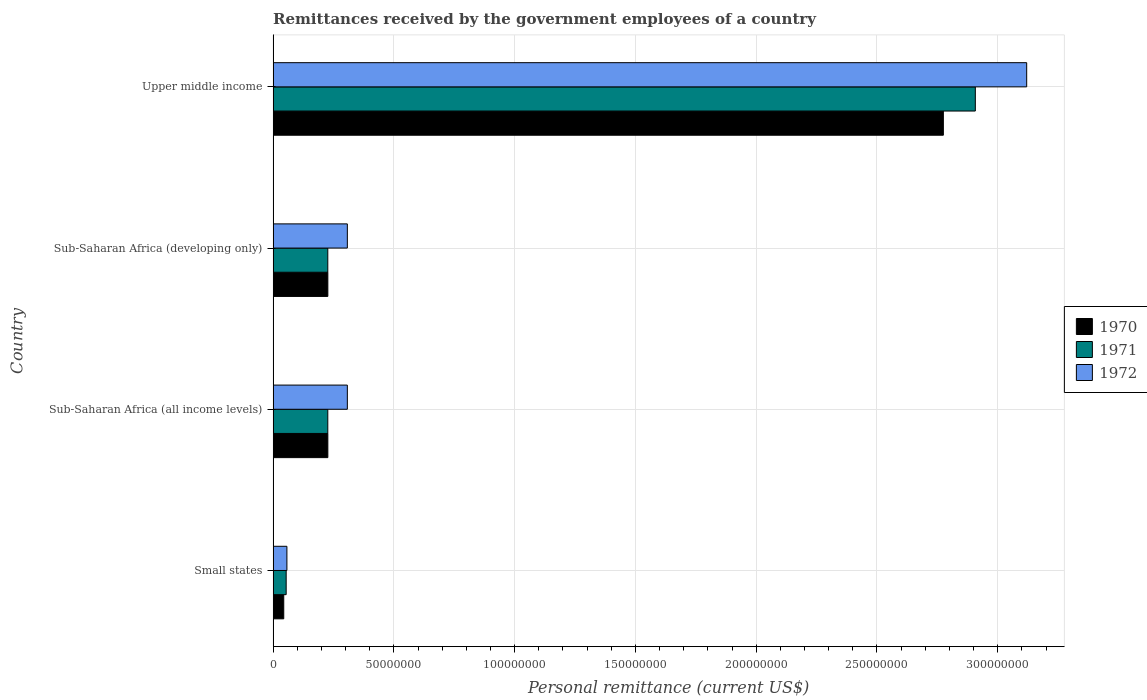How many bars are there on the 2nd tick from the top?
Offer a terse response. 3. What is the label of the 3rd group of bars from the top?
Your answer should be compact. Sub-Saharan Africa (all income levels). What is the remittances received by the government employees in 1971 in Small states?
Your answer should be compact. 5.40e+06. Across all countries, what is the maximum remittances received by the government employees in 1971?
Provide a short and direct response. 2.91e+08. Across all countries, what is the minimum remittances received by the government employees in 1970?
Make the answer very short. 4.40e+06. In which country was the remittances received by the government employees in 1972 maximum?
Give a very brief answer. Upper middle income. In which country was the remittances received by the government employees in 1970 minimum?
Provide a succinct answer. Small states. What is the total remittances received by the government employees in 1970 in the graph?
Provide a succinct answer. 3.27e+08. What is the difference between the remittances received by the government employees in 1970 in Sub-Saharan Africa (all income levels) and that in Sub-Saharan Africa (developing only)?
Offer a very short reply. 0. What is the difference between the remittances received by the government employees in 1972 in Sub-Saharan Africa (developing only) and the remittances received by the government employees in 1971 in Sub-Saharan Africa (all income levels)?
Offer a terse response. 8.09e+06. What is the average remittances received by the government employees in 1972 per country?
Your answer should be very brief. 9.48e+07. What is the difference between the remittances received by the government employees in 1970 and remittances received by the government employees in 1972 in Sub-Saharan Africa (all income levels)?
Ensure brevity in your answer.  -8.07e+06. What is the ratio of the remittances received by the government employees in 1970 in Sub-Saharan Africa (developing only) to that in Upper middle income?
Your response must be concise. 0.08. What is the difference between the highest and the second highest remittances received by the government employees in 1972?
Offer a very short reply. 2.81e+08. What is the difference between the highest and the lowest remittances received by the government employees in 1970?
Your answer should be compact. 2.73e+08. In how many countries, is the remittances received by the government employees in 1972 greater than the average remittances received by the government employees in 1972 taken over all countries?
Ensure brevity in your answer.  1. Is the sum of the remittances received by the government employees in 1972 in Sub-Saharan Africa (all income levels) and Upper middle income greater than the maximum remittances received by the government employees in 1971 across all countries?
Your response must be concise. Yes. What does the 1st bar from the top in Upper middle income represents?
Offer a very short reply. 1972. What does the 2nd bar from the bottom in Small states represents?
Your answer should be very brief. 1971. Are all the bars in the graph horizontal?
Ensure brevity in your answer.  Yes. How many countries are there in the graph?
Keep it short and to the point. 4. Are the values on the major ticks of X-axis written in scientific E-notation?
Give a very brief answer. No. Does the graph contain grids?
Provide a short and direct response. Yes. How many legend labels are there?
Offer a terse response. 3. How are the legend labels stacked?
Make the answer very short. Vertical. What is the title of the graph?
Provide a succinct answer. Remittances received by the government employees of a country. Does "2015" appear as one of the legend labels in the graph?
Your answer should be compact. No. What is the label or title of the X-axis?
Ensure brevity in your answer.  Personal remittance (current US$). What is the Personal remittance (current US$) of 1970 in Small states?
Keep it short and to the point. 4.40e+06. What is the Personal remittance (current US$) in 1971 in Small states?
Your answer should be compact. 5.40e+06. What is the Personal remittance (current US$) in 1972 in Small states?
Your answer should be compact. 5.71e+06. What is the Personal remittance (current US$) of 1970 in Sub-Saharan Africa (all income levels)?
Make the answer very short. 2.27e+07. What is the Personal remittance (current US$) of 1971 in Sub-Saharan Africa (all income levels)?
Ensure brevity in your answer.  2.26e+07. What is the Personal remittance (current US$) of 1972 in Sub-Saharan Africa (all income levels)?
Your answer should be compact. 3.07e+07. What is the Personal remittance (current US$) of 1970 in Sub-Saharan Africa (developing only)?
Keep it short and to the point. 2.27e+07. What is the Personal remittance (current US$) of 1971 in Sub-Saharan Africa (developing only)?
Provide a succinct answer. 2.26e+07. What is the Personal remittance (current US$) in 1972 in Sub-Saharan Africa (developing only)?
Make the answer very short. 3.07e+07. What is the Personal remittance (current US$) of 1970 in Upper middle income?
Keep it short and to the point. 2.77e+08. What is the Personal remittance (current US$) of 1971 in Upper middle income?
Offer a terse response. 2.91e+08. What is the Personal remittance (current US$) in 1972 in Upper middle income?
Provide a succinct answer. 3.12e+08. Across all countries, what is the maximum Personal remittance (current US$) of 1970?
Provide a short and direct response. 2.77e+08. Across all countries, what is the maximum Personal remittance (current US$) of 1971?
Keep it short and to the point. 2.91e+08. Across all countries, what is the maximum Personal remittance (current US$) of 1972?
Provide a short and direct response. 3.12e+08. Across all countries, what is the minimum Personal remittance (current US$) of 1970?
Make the answer very short. 4.40e+06. Across all countries, what is the minimum Personal remittance (current US$) of 1971?
Provide a short and direct response. 5.40e+06. Across all countries, what is the minimum Personal remittance (current US$) of 1972?
Make the answer very short. 5.71e+06. What is the total Personal remittance (current US$) in 1970 in the graph?
Your response must be concise. 3.27e+08. What is the total Personal remittance (current US$) in 1971 in the graph?
Provide a succinct answer. 3.41e+08. What is the total Personal remittance (current US$) of 1972 in the graph?
Provide a short and direct response. 3.79e+08. What is the difference between the Personal remittance (current US$) in 1970 in Small states and that in Sub-Saharan Africa (all income levels)?
Your answer should be compact. -1.83e+07. What is the difference between the Personal remittance (current US$) of 1971 in Small states and that in Sub-Saharan Africa (all income levels)?
Keep it short and to the point. -1.72e+07. What is the difference between the Personal remittance (current US$) of 1972 in Small states and that in Sub-Saharan Africa (all income levels)?
Provide a succinct answer. -2.50e+07. What is the difference between the Personal remittance (current US$) of 1970 in Small states and that in Sub-Saharan Africa (developing only)?
Your response must be concise. -1.83e+07. What is the difference between the Personal remittance (current US$) of 1971 in Small states and that in Sub-Saharan Africa (developing only)?
Make the answer very short. -1.72e+07. What is the difference between the Personal remittance (current US$) of 1972 in Small states and that in Sub-Saharan Africa (developing only)?
Give a very brief answer. -2.50e+07. What is the difference between the Personal remittance (current US$) in 1970 in Small states and that in Upper middle income?
Keep it short and to the point. -2.73e+08. What is the difference between the Personal remittance (current US$) in 1971 in Small states and that in Upper middle income?
Keep it short and to the point. -2.85e+08. What is the difference between the Personal remittance (current US$) of 1972 in Small states and that in Upper middle income?
Your answer should be compact. -3.06e+08. What is the difference between the Personal remittance (current US$) of 1972 in Sub-Saharan Africa (all income levels) and that in Sub-Saharan Africa (developing only)?
Your response must be concise. 0. What is the difference between the Personal remittance (current US$) of 1970 in Sub-Saharan Africa (all income levels) and that in Upper middle income?
Your answer should be compact. -2.55e+08. What is the difference between the Personal remittance (current US$) in 1971 in Sub-Saharan Africa (all income levels) and that in Upper middle income?
Make the answer very short. -2.68e+08. What is the difference between the Personal remittance (current US$) of 1972 in Sub-Saharan Africa (all income levels) and that in Upper middle income?
Provide a succinct answer. -2.81e+08. What is the difference between the Personal remittance (current US$) of 1970 in Sub-Saharan Africa (developing only) and that in Upper middle income?
Make the answer very short. -2.55e+08. What is the difference between the Personal remittance (current US$) of 1971 in Sub-Saharan Africa (developing only) and that in Upper middle income?
Your answer should be compact. -2.68e+08. What is the difference between the Personal remittance (current US$) of 1972 in Sub-Saharan Africa (developing only) and that in Upper middle income?
Keep it short and to the point. -2.81e+08. What is the difference between the Personal remittance (current US$) of 1970 in Small states and the Personal remittance (current US$) of 1971 in Sub-Saharan Africa (all income levels)?
Make the answer very short. -1.82e+07. What is the difference between the Personal remittance (current US$) in 1970 in Small states and the Personal remittance (current US$) in 1972 in Sub-Saharan Africa (all income levels)?
Keep it short and to the point. -2.63e+07. What is the difference between the Personal remittance (current US$) in 1971 in Small states and the Personal remittance (current US$) in 1972 in Sub-Saharan Africa (all income levels)?
Provide a short and direct response. -2.53e+07. What is the difference between the Personal remittance (current US$) in 1970 in Small states and the Personal remittance (current US$) in 1971 in Sub-Saharan Africa (developing only)?
Give a very brief answer. -1.82e+07. What is the difference between the Personal remittance (current US$) in 1970 in Small states and the Personal remittance (current US$) in 1972 in Sub-Saharan Africa (developing only)?
Provide a succinct answer. -2.63e+07. What is the difference between the Personal remittance (current US$) of 1971 in Small states and the Personal remittance (current US$) of 1972 in Sub-Saharan Africa (developing only)?
Provide a short and direct response. -2.53e+07. What is the difference between the Personal remittance (current US$) in 1970 in Small states and the Personal remittance (current US$) in 1971 in Upper middle income?
Your answer should be compact. -2.86e+08. What is the difference between the Personal remittance (current US$) of 1970 in Small states and the Personal remittance (current US$) of 1972 in Upper middle income?
Keep it short and to the point. -3.08e+08. What is the difference between the Personal remittance (current US$) of 1971 in Small states and the Personal remittance (current US$) of 1972 in Upper middle income?
Your answer should be compact. -3.07e+08. What is the difference between the Personal remittance (current US$) in 1970 in Sub-Saharan Africa (all income levels) and the Personal remittance (current US$) in 1971 in Sub-Saharan Africa (developing only)?
Make the answer very short. 2.18e+04. What is the difference between the Personal remittance (current US$) in 1970 in Sub-Saharan Africa (all income levels) and the Personal remittance (current US$) in 1972 in Sub-Saharan Africa (developing only)?
Keep it short and to the point. -8.07e+06. What is the difference between the Personal remittance (current US$) in 1971 in Sub-Saharan Africa (all income levels) and the Personal remittance (current US$) in 1972 in Sub-Saharan Africa (developing only)?
Make the answer very short. -8.09e+06. What is the difference between the Personal remittance (current US$) in 1970 in Sub-Saharan Africa (all income levels) and the Personal remittance (current US$) in 1971 in Upper middle income?
Ensure brevity in your answer.  -2.68e+08. What is the difference between the Personal remittance (current US$) of 1970 in Sub-Saharan Africa (all income levels) and the Personal remittance (current US$) of 1972 in Upper middle income?
Provide a short and direct response. -2.89e+08. What is the difference between the Personal remittance (current US$) of 1971 in Sub-Saharan Africa (all income levels) and the Personal remittance (current US$) of 1972 in Upper middle income?
Keep it short and to the point. -2.89e+08. What is the difference between the Personal remittance (current US$) in 1970 in Sub-Saharan Africa (developing only) and the Personal remittance (current US$) in 1971 in Upper middle income?
Keep it short and to the point. -2.68e+08. What is the difference between the Personal remittance (current US$) in 1970 in Sub-Saharan Africa (developing only) and the Personal remittance (current US$) in 1972 in Upper middle income?
Make the answer very short. -2.89e+08. What is the difference between the Personal remittance (current US$) of 1971 in Sub-Saharan Africa (developing only) and the Personal remittance (current US$) of 1972 in Upper middle income?
Give a very brief answer. -2.89e+08. What is the average Personal remittance (current US$) of 1970 per country?
Offer a very short reply. 8.18e+07. What is the average Personal remittance (current US$) of 1971 per country?
Make the answer very short. 8.54e+07. What is the average Personal remittance (current US$) in 1972 per country?
Offer a very short reply. 9.48e+07. What is the difference between the Personal remittance (current US$) in 1970 and Personal remittance (current US$) in 1971 in Small states?
Ensure brevity in your answer.  -1.00e+06. What is the difference between the Personal remittance (current US$) in 1970 and Personal remittance (current US$) in 1972 in Small states?
Provide a short and direct response. -1.31e+06. What is the difference between the Personal remittance (current US$) of 1971 and Personal remittance (current US$) of 1972 in Small states?
Provide a short and direct response. -3.07e+05. What is the difference between the Personal remittance (current US$) of 1970 and Personal remittance (current US$) of 1971 in Sub-Saharan Africa (all income levels)?
Provide a succinct answer. 2.18e+04. What is the difference between the Personal remittance (current US$) in 1970 and Personal remittance (current US$) in 1972 in Sub-Saharan Africa (all income levels)?
Ensure brevity in your answer.  -8.07e+06. What is the difference between the Personal remittance (current US$) in 1971 and Personal remittance (current US$) in 1972 in Sub-Saharan Africa (all income levels)?
Offer a terse response. -8.09e+06. What is the difference between the Personal remittance (current US$) of 1970 and Personal remittance (current US$) of 1971 in Sub-Saharan Africa (developing only)?
Offer a very short reply. 2.18e+04. What is the difference between the Personal remittance (current US$) of 1970 and Personal remittance (current US$) of 1972 in Sub-Saharan Africa (developing only)?
Ensure brevity in your answer.  -8.07e+06. What is the difference between the Personal remittance (current US$) of 1971 and Personal remittance (current US$) of 1972 in Sub-Saharan Africa (developing only)?
Give a very brief answer. -8.09e+06. What is the difference between the Personal remittance (current US$) of 1970 and Personal remittance (current US$) of 1971 in Upper middle income?
Offer a very short reply. -1.32e+07. What is the difference between the Personal remittance (current US$) of 1970 and Personal remittance (current US$) of 1972 in Upper middle income?
Your answer should be compact. -3.45e+07. What is the difference between the Personal remittance (current US$) of 1971 and Personal remittance (current US$) of 1972 in Upper middle income?
Provide a short and direct response. -2.13e+07. What is the ratio of the Personal remittance (current US$) of 1970 in Small states to that in Sub-Saharan Africa (all income levels)?
Provide a short and direct response. 0.19. What is the ratio of the Personal remittance (current US$) of 1971 in Small states to that in Sub-Saharan Africa (all income levels)?
Make the answer very short. 0.24. What is the ratio of the Personal remittance (current US$) in 1972 in Small states to that in Sub-Saharan Africa (all income levels)?
Give a very brief answer. 0.19. What is the ratio of the Personal remittance (current US$) in 1970 in Small states to that in Sub-Saharan Africa (developing only)?
Keep it short and to the point. 0.19. What is the ratio of the Personal remittance (current US$) in 1971 in Small states to that in Sub-Saharan Africa (developing only)?
Ensure brevity in your answer.  0.24. What is the ratio of the Personal remittance (current US$) of 1972 in Small states to that in Sub-Saharan Africa (developing only)?
Provide a short and direct response. 0.19. What is the ratio of the Personal remittance (current US$) of 1970 in Small states to that in Upper middle income?
Your answer should be compact. 0.02. What is the ratio of the Personal remittance (current US$) of 1971 in Small states to that in Upper middle income?
Provide a succinct answer. 0.02. What is the ratio of the Personal remittance (current US$) in 1972 in Small states to that in Upper middle income?
Your response must be concise. 0.02. What is the ratio of the Personal remittance (current US$) in 1970 in Sub-Saharan Africa (all income levels) to that in Upper middle income?
Your response must be concise. 0.08. What is the ratio of the Personal remittance (current US$) in 1971 in Sub-Saharan Africa (all income levels) to that in Upper middle income?
Ensure brevity in your answer.  0.08. What is the ratio of the Personal remittance (current US$) in 1972 in Sub-Saharan Africa (all income levels) to that in Upper middle income?
Make the answer very short. 0.1. What is the ratio of the Personal remittance (current US$) in 1970 in Sub-Saharan Africa (developing only) to that in Upper middle income?
Provide a short and direct response. 0.08. What is the ratio of the Personal remittance (current US$) in 1971 in Sub-Saharan Africa (developing only) to that in Upper middle income?
Keep it short and to the point. 0.08. What is the ratio of the Personal remittance (current US$) of 1972 in Sub-Saharan Africa (developing only) to that in Upper middle income?
Offer a terse response. 0.1. What is the difference between the highest and the second highest Personal remittance (current US$) of 1970?
Offer a very short reply. 2.55e+08. What is the difference between the highest and the second highest Personal remittance (current US$) in 1971?
Keep it short and to the point. 2.68e+08. What is the difference between the highest and the second highest Personal remittance (current US$) in 1972?
Ensure brevity in your answer.  2.81e+08. What is the difference between the highest and the lowest Personal remittance (current US$) in 1970?
Make the answer very short. 2.73e+08. What is the difference between the highest and the lowest Personal remittance (current US$) of 1971?
Give a very brief answer. 2.85e+08. What is the difference between the highest and the lowest Personal remittance (current US$) in 1972?
Make the answer very short. 3.06e+08. 